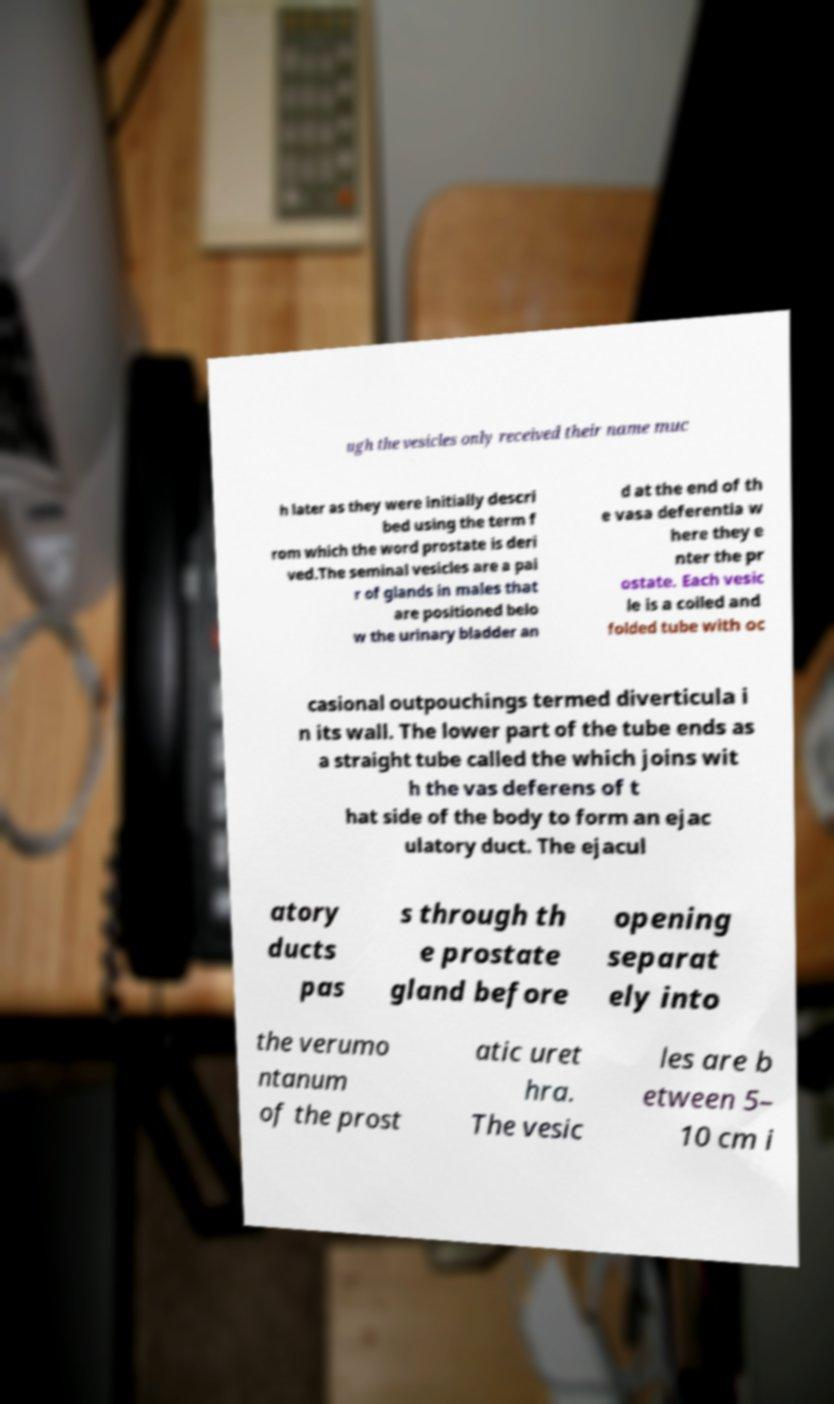Could you assist in decoding the text presented in this image and type it out clearly? ugh the vesicles only received their name muc h later as they were initially descri bed using the term f rom which the word prostate is deri ved.The seminal vesicles are a pai r of glands in males that are positioned belo w the urinary bladder an d at the end of th e vasa deferentia w here they e nter the pr ostate. Each vesic le is a coiled and folded tube with oc casional outpouchings termed diverticula i n its wall. The lower part of the tube ends as a straight tube called the which joins wit h the vas deferens of t hat side of the body to form an ejac ulatory duct. The ejacul atory ducts pas s through th e prostate gland before opening separat ely into the verumo ntanum of the prost atic uret hra. The vesic les are b etween 5– 10 cm i 